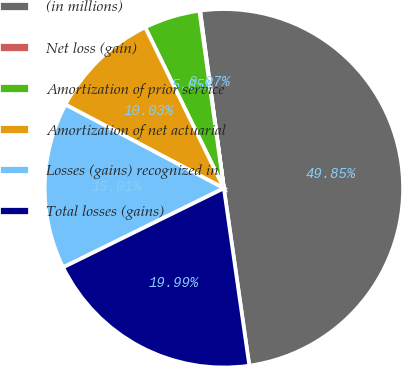Convert chart. <chart><loc_0><loc_0><loc_500><loc_500><pie_chart><fcel>(in millions)<fcel>Net loss (gain)<fcel>Amortization of prior service<fcel>Amortization of net actuarial<fcel>Losses (gains) recognized in<fcel>Total losses (gains)<nl><fcel>49.85%<fcel>0.07%<fcel>5.05%<fcel>10.03%<fcel>15.01%<fcel>19.99%<nl></chart> 